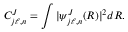Convert formula to latex. <formula><loc_0><loc_0><loc_500><loc_500>C _ { j \ell , n } ^ { J } = \int | \psi _ { j \ell , n } ^ { J } ( R ) | ^ { 2 } d R .</formula> 